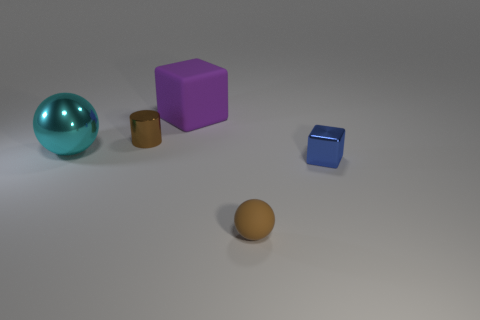Add 1 brown matte objects. How many objects exist? 6 Subtract all cubes. How many objects are left? 3 Subtract all brown cylinders. How many purple blocks are left? 1 Subtract all brown rubber things. Subtract all large purple cubes. How many objects are left? 3 Add 1 big cyan spheres. How many big cyan spheres are left? 2 Add 1 big spheres. How many big spheres exist? 2 Subtract 0 purple balls. How many objects are left? 5 Subtract all red blocks. Subtract all purple spheres. How many blocks are left? 2 